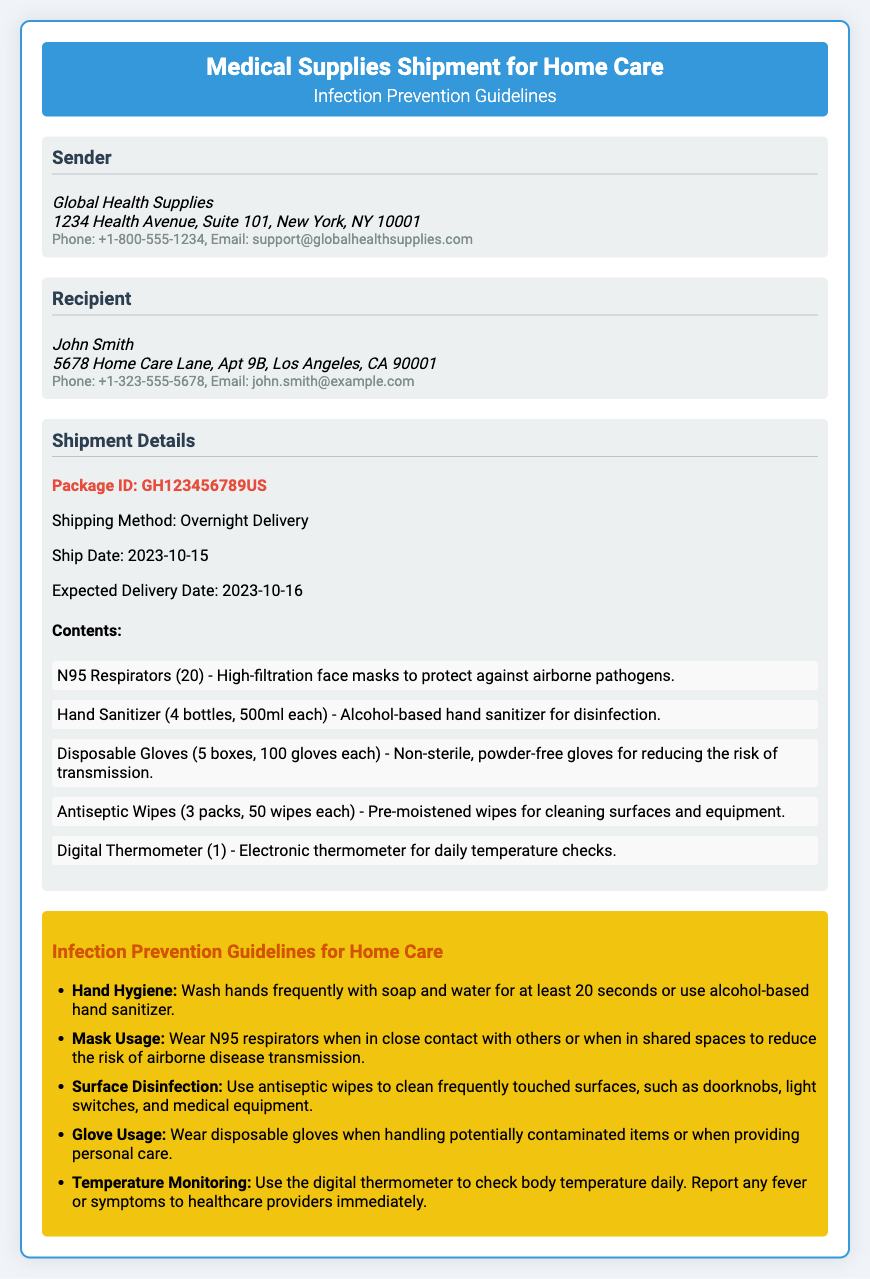what is the sender's name? The sender's name is provided in the document under the "Sender" section.
Answer: Global Health Supplies what is the recipient's address? The recipient's address is located in the "Recipient" section, where the full address is listed.
Answer: 5678 Home Care Lane, Apt 9B, Los Angeles, CA 90001 what is the expected delivery date? The expected delivery date is clearly stated in the "Shipment Details" section.
Answer: 2023-10-16 how many N95 Respirators are included? The number of N95 Respirators can be found in the "Contents" list under "Shipment Details."
Answer: 20 what is the package ID? The package ID is presented in the "Shipment Details" section.
Answer: GH123456789US how many bottles of hand sanitizer are included? The quantity of hand sanitizer is detailed in the list of contents in the document.
Answer: 4 bottles what should you do if you develop a fever? The guideline regarding fever is stated under "Infection Prevention Guidelines for Home Care."
Answer: Report to healthcare providers immediately what is the shipping method? The shipping method is mentioned in the "Shipment Details" section.
Answer: Overnight Delivery what is the contact email for the sender? The contact email is provided in the "Sender" section of the document.
Answer: support@globalhealthsupplies.com 